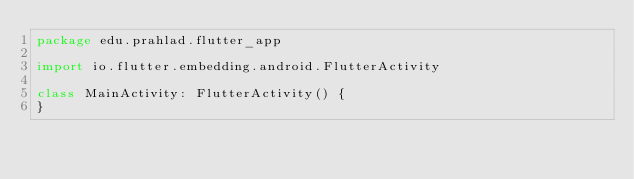<code> <loc_0><loc_0><loc_500><loc_500><_Kotlin_>package edu.prahlad.flutter_app

import io.flutter.embedding.android.FlutterActivity

class MainActivity: FlutterActivity() {
}
</code> 